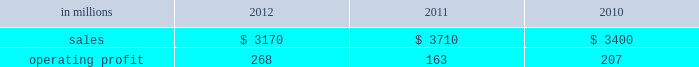Freesheet paper were higher in russia , but lower in europe reflecting weak economic conditions and market demand .
Average sales price realizations for pulp decreased .
Lower input costs for wood and purchased fiber were partially offset by higher costs for energy , chemicals and packaging .
Freight costs were also higher .
Planned maintenance downtime costs were higher due to executing a significant once-every-ten-years maintenance outage plus the regularly scheduled 18-month outage at the saillat mill while outage costs in russia and poland were lower .
Manufacturing operating costs were favor- entering 2013 , sales volumes in the first quarter are expected to be seasonally weaker in russia , but about flat in europe .
Average sales price realizations for uncoated freesheet paper are expected to decrease in europe , but increase in russia .
Input costs should be higher in russia , especially for wood and energy , but be slightly lower in europe .
No maintenance outages are scheduled for the first quarter .
Ind ian papers includes the results of andhra pradesh paper mills ( appm ) of which a 75% ( 75 % ) interest was acquired on october 14 , 2011 .
Net sales were $ 185 million in 2012 and $ 35 million in 2011 .
Operat- ing profits were a loss of $ 16 million in 2012 and a loss of $ 3 million in 2011 .
Asian pr int ing papers net sales were $ 85 mil- lion in 2012 , $ 75 million in 2011 and $ 80 million in 2010 .
Operating profits were improved from break- even in past years to $ 1 million in 2012 .
U.s .
Pulp net sales were $ 725 million in 2012 compared with $ 725 million in 2011 and $ 715 million in 2010 .
Operating profits were a loss of $ 59 million in 2012 compared with gains of $ 87 million in 2011 and $ 107 million in 2010 .
Sales volumes in 2012 increased from 2011 primarily due to the start-up of pulp production at the franklin mill in the third quarter of 2012 .
Average sales price realizations were significantly lower for both fluff pulp and market pulp .
Input costs were lower , primarily for wood and energy .
Freight costs were slightly lower .
Mill operating costs were unfavorable primarily due to costs associated with the start-up of the franklin mill .
Planned maintenance downtime costs were lower .
In the first quarter of 2013 , sales volumes are expected to be flat with the fourth quarter of 2012 .
Average sales price realizations are expected to improve reflecting the realization of sales price increases for paper and tissue pulp that were announced in the fourth quarter of 2012 .
Input costs should be flat .
Planned maintenance downtime costs should be about $ 9 million higher than in the fourth quarter of 2012 .
Manufacturing costs related to the franklin mill should be lower as we continue to improve operations .
Consumer packaging demand and pricing for consumer packaging prod- ucts correlate closely with consumer spending and general economic activity .
In addition to prices and volumes , major factors affecting the profitability of consumer packaging are raw material and energy costs , freight costs , manufacturing efficiency and product mix .
Consumer packaging net sales in 2012 decreased 15% ( 15 % ) from 2011 and 7% ( 7 % ) from 2010 .
Operating profits increased 64% ( 64 % ) from 2011 and 29% ( 29 % ) from 2010 .
Net sales and operating profits include the shorewood business in 2011 and 2010 .
Exclud- ing asset impairment and other charges associated with the sale of the shorewood business , and facility closure costs , 2012 operating profits were 27% ( 27 % ) lower than in 2011 , but 23% ( 23 % ) higher than in 2010 .
Benefits from lower raw material costs ( $ 22 million ) , lower maintenance outage costs ( $ 5 million ) and other items ( $ 2 million ) were more than offset by lower sales price realizations and an unfavorable product mix ( $ 66 million ) , lower sales volumes and increased market-related downtime ( $ 22 million ) , and higher operating costs ( $ 40 million ) .
In addition , operating profits in 2012 included a gain of $ 3 million related to the sale of the shorewood business while operating profits in 2011 included a $ 129 million fixed asset impairment charge for the north ameri- can shorewood business and $ 72 million for other charges associated with the sale of the shorewood business .
Consumer packaging .
North american consumer packaging net sales were $ 2.0 billion in 2012 compared with $ 2.5 billion in 2011 and $ 2.4 billion in 2010 .
Operating profits were $ 165 million ( $ 162 million excluding a gain related to the sale of the shorewood business ) in 2012 compared with $ 35 million ( $ 236 million excluding asset impairment and other charges asso- ciated with the sale of the shorewood business ) in 2011 and $ 97 million ( $ 105 million excluding facility closure costs ) in 2010 .
Coated paperboard sales volumes in 2012 were lower than in 2011 reflecting weaker market demand .
Average sales price realizations were lower , primar- ily for folding carton board .
Input costs for wood increased , but were partially offset by lower costs for chemicals and energy .
Planned maintenance down- time costs were slightly lower .
Market-related down- time was about 113000 tons in 2012 compared with about 38000 tons in 2011. .
What percentage where north american consumer packaging net sales of total consumer packaging sales in 2012? 
Computations: ((2 * 1000) / 3170)
Answer: 0.63091. 